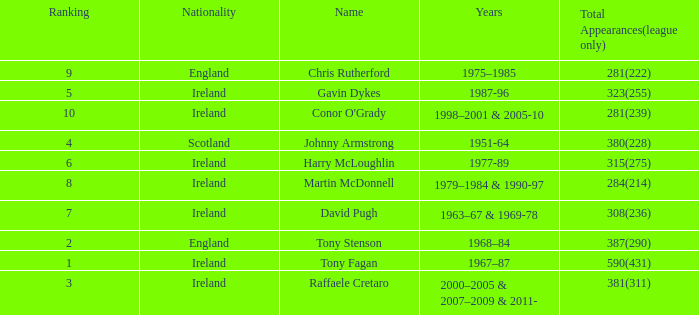Parse the table in full. {'header': ['Ranking', 'Nationality', 'Name', 'Years', 'Total Appearances(league only)'], 'rows': [['9', 'England', 'Chris Rutherford', '1975–1985', '281(222)'], ['5', 'Ireland', 'Gavin Dykes', '1987-96', '323(255)'], ['10', 'Ireland', "Conor O'Grady", '1998–2001 & 2005-10', '281(239)'], ['4', 'Scotland', 'Johnny Armstrong', '1951-64', '380(228)'], ['6', 'Ireland', 'Harry McLoughlin', '1977-89', '315(275)'], ['8', 'Ireland', 'Martin McDonnell', '1979–1984 & 1990-97', '284(214)'], ['7', 'Ireland', 'David Pugh', '1963–67 & 1969-78', '308(236)'], ['2', 'England', 'Tony Stenson', '1968–84', '387(290)'], ['1', 'Ireland', 'Tony Fagan', '1967–87', '590(431)'], ['3', 'Ireland', 'Raffaele Cretaro', '2000–2005 & 2007–2009 & 2011-', '381(311)']]} How many total appearances (league only) have a name of gavin dykes? 323(255). 